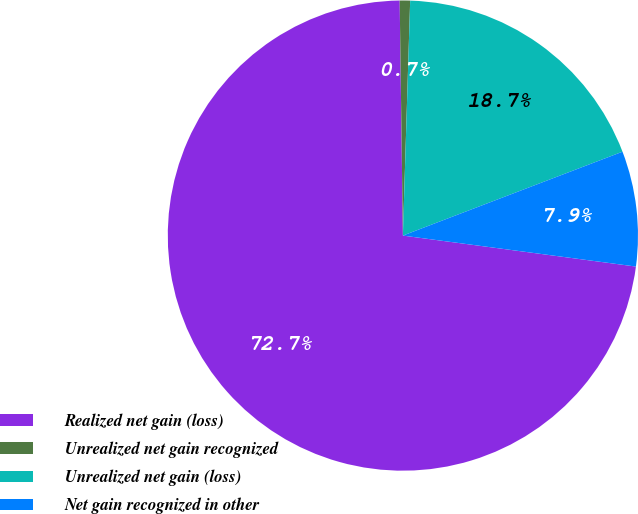Convert chart to OTSL. <chart><loc_0><loc_0><loc_500><loc_500><pie_chart><fcel>Realized net gain (loss)<fcel>Unrealized net gain recognized<fcel>Unrealized net gain (loss)<fcel>Net gain recognized in other<nl><fcel>72.68%<fcel>0.71%<fcel>18.7%<fcel>7.91%<nl></chart> 